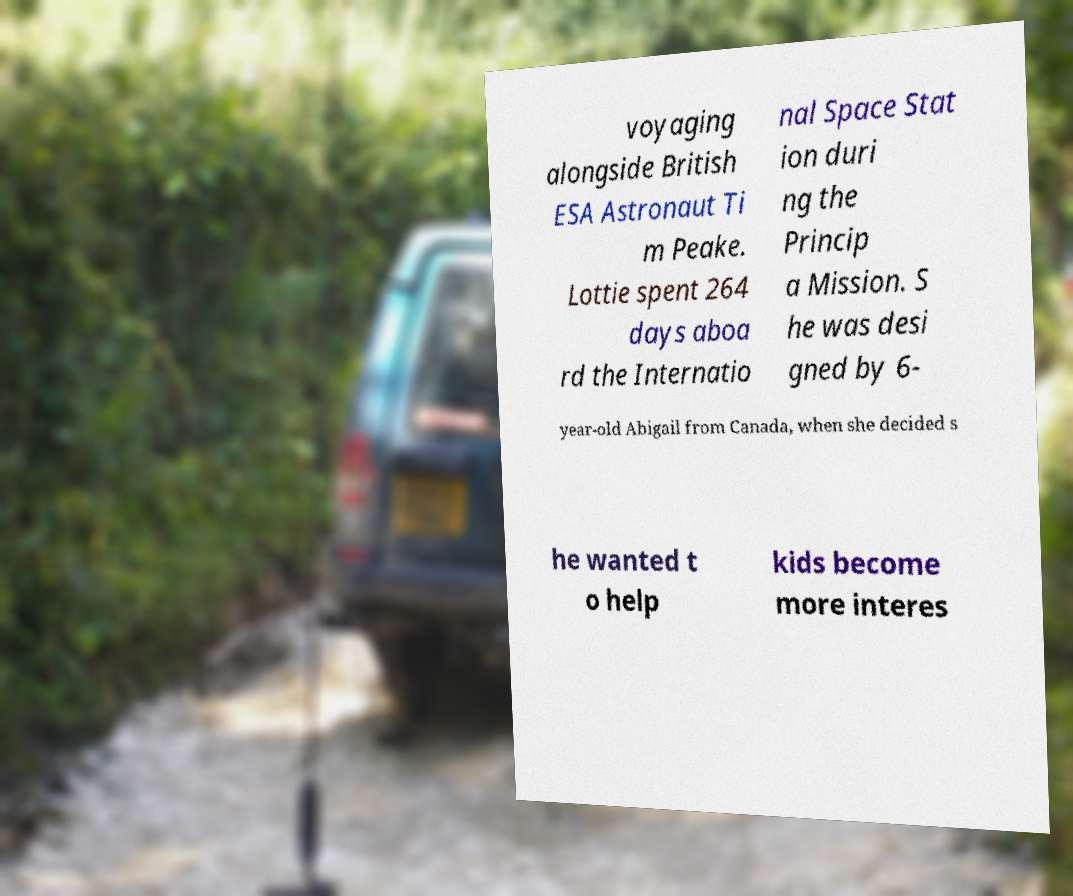Please identify and transcribe the text found in this image. voyaging alongside British ESA Astronaut Ti m Peake. Lottie spent 264 days aboa rd the Internatio nal Space Stat ion duri ng the Princip a Mission. S he was desi gned by 6- year-old Abigail from Canada, when she decided s he wanted t o help kids become more interes 